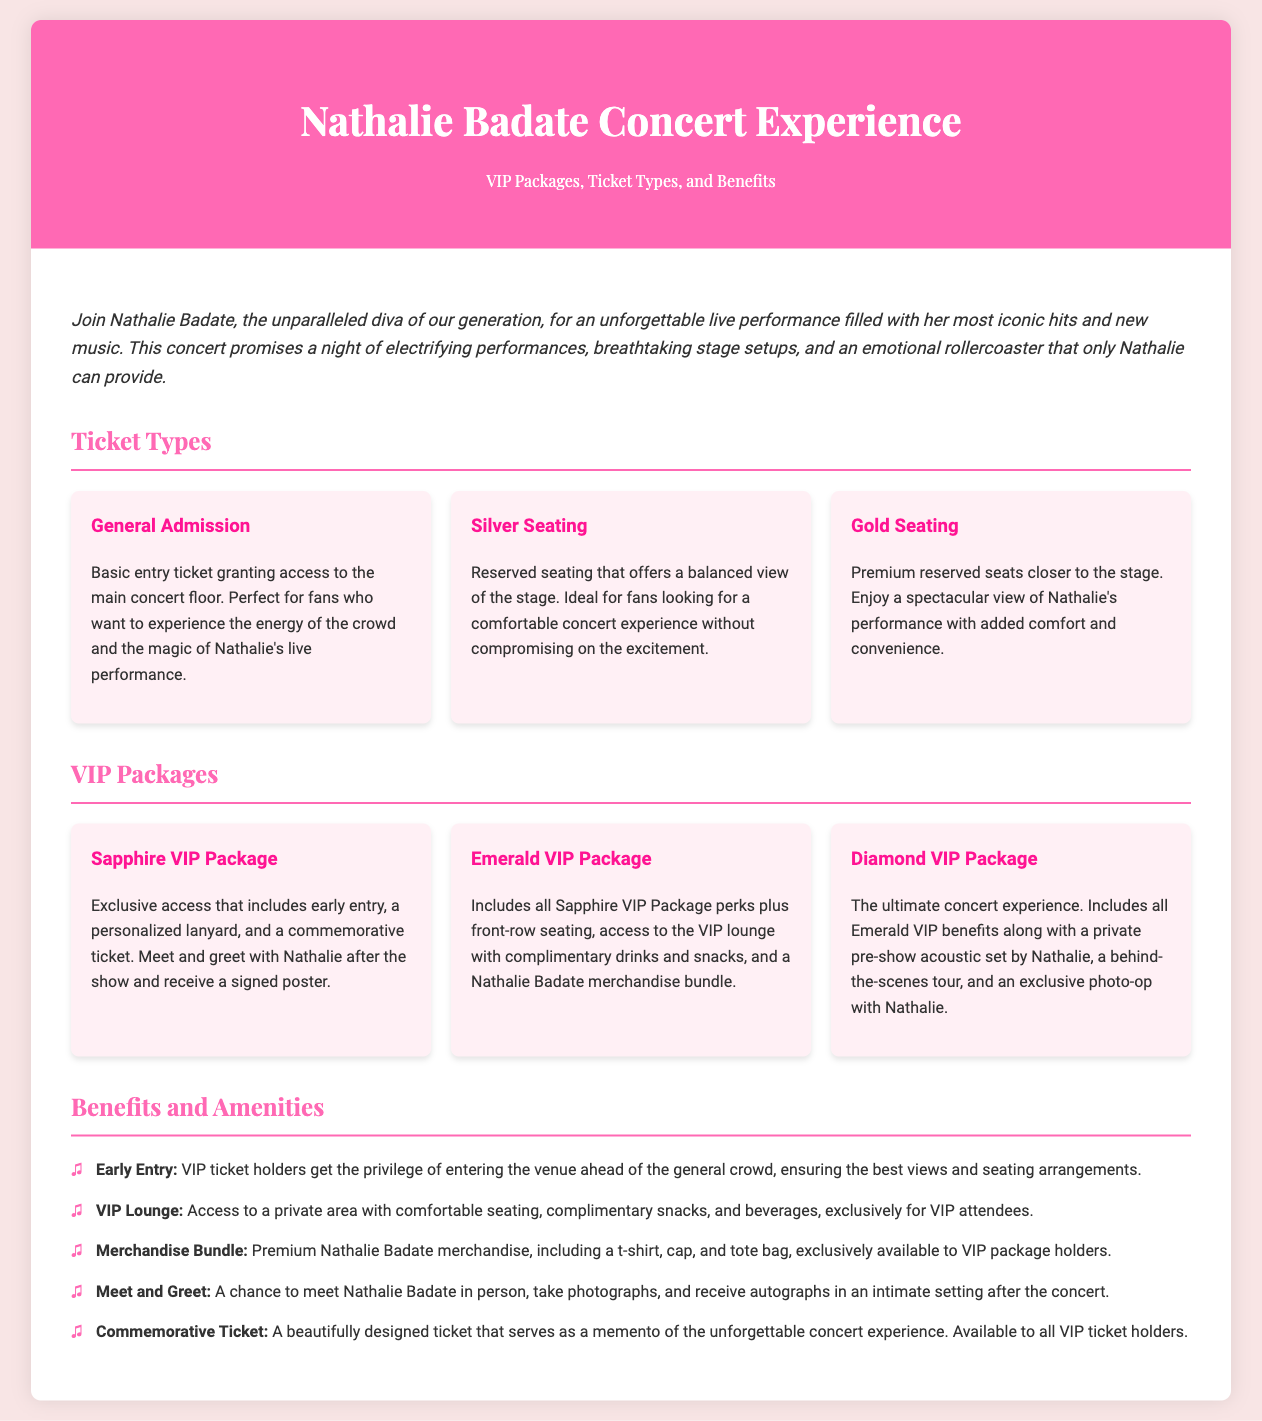What is the name of the concert experience? The concert experience is specifically titled in the document header as "Nathalie Badate Concert Experience."
Answer: Nathalie Badate Concert Experience What are the three types of ticket options available? The document specifies "General Admission," "Silver Seating," and "Gold Seating" as the three ticket options.
Answer: General Admission, Silver Seating, Gold Seating What premium package offers front-row seating? The "Emerald VIP Package" offers additional benefits that include front-row seating among other perks.
Answer: Emerald VIP Package What is included in the Diamond VIP Package? The Diamond VIP Package includes the Emerald VIP benefits plus a private pre-show acoustic set, a behind-the-scenes tour, and a photo-op with Nathalie.
Answer: Private pre-show acoustic set, behind-the-scenes tour, photo-op with Nathalie How many benefits and amenities are listed in the document? The document lists five specific benefits and amenities for VIP ticket holders.
Answer: Five What is the special item VIP ticket holders receive as a memento? VIP ticket holders receive a "Commemorative Ticket," which is described as beautifully designed and serves as a memento.
Answer: Commemorative Ticket What can attendees expect to receive with the Merchandise Bundle? The Merchandise Bundle includes premium Nathalie Badate merchandise such as a t-shirt, cap, and tote bag.
Answer: T-shirt, cap, tote bag What is the purpose of early entry for VIP ticket holders? Early entry allows VIP ticket holders the privilege of entering the venue ahead of the general crowd to secure the best views and seating.
Answer: Best views and seating 